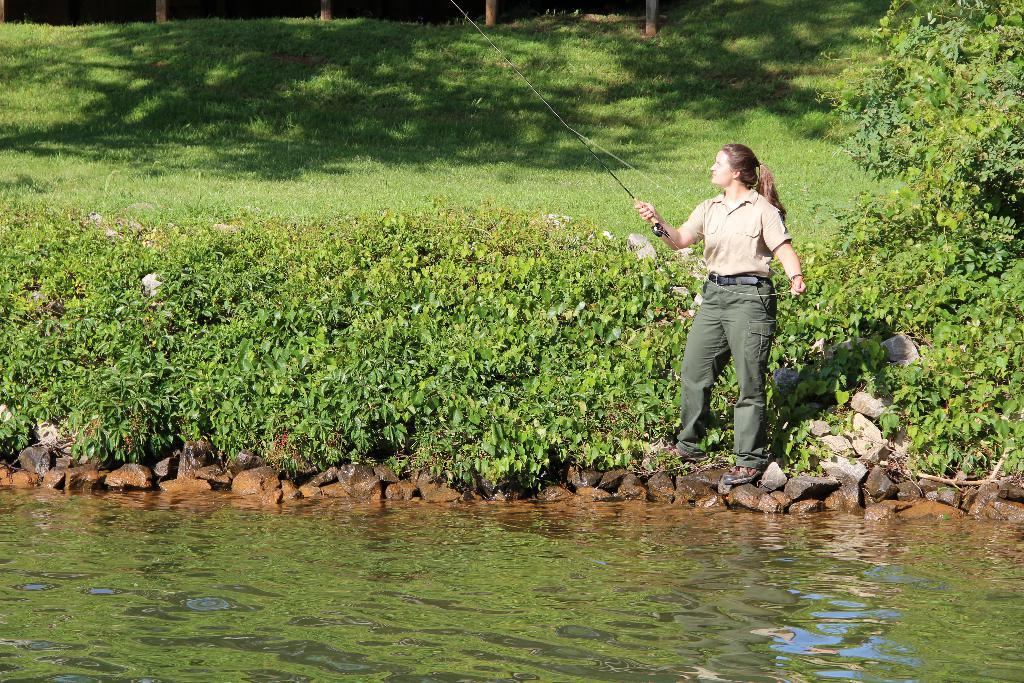Who is present in the image? There is a woman in the image. What is the woman holding in the image? The woman is holding a fishing rod. What type of natural environment can be seen in the image? There are plants, a lake, grass, and trees in the image. What type of marble is visible in the image? There is no marble present in the image. How does the woman feel about her fishing skills in the image? The image does not convey any emotions or feelings, so it is impossible to determine how the woman feels about her fishing skills. 